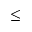<formula> <loc_0><loc_0><loc_500><loc_500>\leq</formula> 